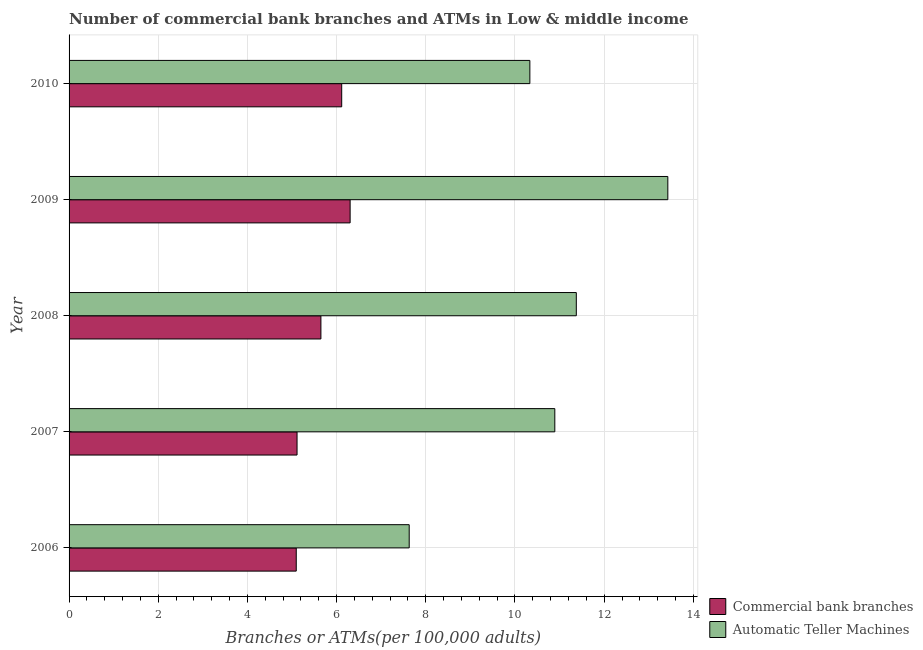How many different coloured bars are there?
Provide a short and direct response. 2. Are the number of bars on each tick of the Y-axis equal?
Provide a succinct answer. Yes. How many bars are there on the 2nd tick from the bottom?
Offer a very short reply. 2. What is the label of the 1st group of bars from the top?
Offer a terse response. 2010. What is the number of atms in 2008?
Your answer should be very brief. 11.38. Across all years, what is the maximum number of commercal bank branches?
Provide a succinct answer. 6.3. Across all years, what is the minimum number of atms?
Provide a succinct answer. 7.63. In which year was the number of commercal bank branches minimum?
Provide a short and direct response. 2006. What is the total number of commercal bank branches in the graph?
Offer a terse response. 28.27. What is the difference between the number of commercal bank branches in 2008 and that in 2009?
Make the answer very short. -0.66. What is the difference between the number of commercal bank branches in 2009 and the number of atms in 2008?
Give a very brief answer. -5.07. What is the average number of atms per year?
Give a very brief answer. 10.73. In the year 2008, what is the difference between the number of commercal bank branches and number of atms?
Your response must be concise. -5.73. In how many years, is the number of commercal bank branches greater than 10.8 ?
Your answer should be very brief. 0. What is the ratio of the number of atms in 2007 to that in 2010?
Your response must be concise. 1.05. What is the difference between the highest and the second highest number of atms?
Make the answer very short. 2.05. What is the difference between the highest and the lowest number of commercal bank branches?
Your answer should be very brief. 1.21. What does the 2nd bar from the top in 2010 represents?
Give a very brief answer. Commercial bank branches. What does the 2nd bar from the bottom in 2010 represents?
Provide a succinct answer. Automatic Teller Machines. Are all the bars in the graph horizontal?
Provide a succinct answer. Yes. How many years are there in the graph?
Offer a terse response. 5. Are the values on the major ticks of X-axis written in scientific E-notation?
Offer a very short reply. No. Does the graph contain any zero values?
Provide a short and direct response. No. Does the graph contain grids?
Your answer should be very brief. Yes. How are the legend labels stacked?
Provide a short and direct response. Vertical. What is the title of the graph?
Your answer should be very brief. Number of commercial bank branches and ATMs in Low & middle income. What is the label or title of the X-axis?
Offer a very short reply. Branches or ATMs(per 100,0 adults). What is the Branches or ATMs(per 100,000 adults) of Commercial bank branches in 2006?
Offer a very short reply. 5.09. What is the Branches or ATMs(per 100,000 adults) of Automatic Teller Machines in 2006?
Give a very brief answer. 7.63. What is the Branches or ATMs(per 100,000 adults) of Commercial bank branches in 2007?
Your response must be concise. 5.11. What is the Branches or ATMs(per 100,000 adults) in Automatic Teller Machines in 2007?
Your response must be concise. 10.89. What is the Branches or ATMs(per 100,000 adults) of Commercial bank branches in 2008?
Offer a terse response. 5.65. What is the Branches or ATMs(per 100,000 adults) of Automatic Teller Machines in 2008?
Offer a terse response. 11.38. What is the Branches or ATMs(per 100,000 adults) of Commercial bank branches in 2009?
Your answer should be very brief. 6.3. What is the Branches or ATMs(per 100,000 adults) in Automatic Teller Machines in 2009?
Give a very brief answer. 13.43. What is the Branches or ATMs(per 100,000 adults) in Commercial bank branches in 2010?
Your answer should be very brief. 6.11. What is the Branches or ATMs(per 100,000 adults) in Automatic Teller Machines in 2010?
Keep it short and to the point. 10.33. Across all years, what is the maximum Branches or ATMs(per 100,000 adults) of Commercial bank branches?
Your answer should be very brief. 6.3. Across all years, what is the maximum Branches or ATMs(per 100,000 adults) in Automatic Teller Machines?
Keep it short and to the point. 13.43. Across all years, what is the minimum Branches or ATMs(per 100,000 adults) in Commercial bank branches?
Ensure brevity in your answer.  5.09. Across all years, what is the minimum Branches or ATMs(per 100,000 adults) of Automatic Teller Machines?
Keep it short and to the point. 7.63. What is the total Branches or ATMs(per 100,000 adults) of Commercial bank branches in the graph?
Offer a very short reply. 28.27. What is the total Branches or ATMs(per 100,000 adults) in Automatic Teller Machines in the graph?
Your answer should be compact. 53.66. What is the difference between the Branches or ATMs(per 100,000 adults) in Commercial bank branches in 2006 and that in 2007?
Give a very brief answer. -0.02. What is the difference between the Branches or ATMs(per 100,000 adults) in Automatic Teller Machines in 2006 and that in 2007?
Your response must be concise. -3.27. What is the difference between the Branches or ATMs(per 100,000 adults) of Commercial bank branches in 2006 and that in 2008?
Provide a succinct answer. -0.55. What is the difference between the Branches or ATMs(per 100,000 adults) in Automatic Teller Machines in 2006 and that in 2008?
Provide a succinct answer. -3.75. What is the difference between the Branches or ATMs(per 100,000 adults) of Commercial bank branches in 2006 and that in 2009?
Offer a terse response. -1.21. What is the difference between the Branches or ATMs(per 100,000 adults) in Automatic Teller Machines in 2006 and that in 2009?
Your answer should be very brief. -5.8. What is the difference between the Branches or ATMs(per 100,000 adults) of Commercial bank branches in 2006 and that in 2010?
Your answer should be compact. -1.02. What is the difference between the Branches or ATMs(per 100,000 adults) of Automatic Teller Machines in 2006 and that in 2010?
Your answer should be compact. -2.71. What is the difference between the Branches or ATMs(per 100,000 adults) of Commercial bank branches in 2007 and that in 2008?
Keep it short and to the point. -0.53. What is the difference between the Branches or ATMs(per 100,000 adults) in Automatic Teller Machines in 2007 and that in 2008?
Provide a short and direct response. -0.48. What is the difference between the Branches or ATMs(per 100,000 adults) of Commercial bank branches in 2007 and that in 2009?
Your answer should be compact. -1.19. What is the difference between the Branches or ATMs(per 100,000 adults) in Automatic Teller Machines in 2007 and that in 2009?
Ensure brevity in your answer.  -2.53. What is the difference between the Branches or ATMs(per 100,000 adults) of Commercial bank branches in 2007 and that in 2010?
Provide a succinct answer. -1. What is the difference between the Branches or ATMs(per 100,000 adults) in Automatic Teller Machines in 2007 and that in 2010?
Provide a short and direct response. 0.56. What is the difference between the Branches or ATMs(per 100,000 adults) in Commercial bank branches in 2008 and that in 2009?
Your response must be concise. -0.66. What is the difference between the Branches or ATMs(per 100,000 adults) of Automatic Teller Machines in 2008 and that in 2009?
Offer a very short reply. -2.05. What is the difference between the Branches or ATMs(per 100,000 adults) in Commercial bank branches in 2008 and that in 2010?
Provide a short and direct response. -0.47. What is the difference between the Branches or ATMs(per 100,000 adults) of Automatic Teller Machines in 2008 and that in 2010?
Offer a very short reply. 1.04. What is the difference between the Branches or ATMs(per 100,000 adults) of Commercial bank branches in 2009 and that in 2010?
Keep it short and to the point. 0.19. What is the difference between the Branches or ATMs(per 100,000 adults) in Automatic Teller Machines in 2009 and that in 2010?
Offer a very short reply. 3.09. What is the difference between the Branches or ATMs(per 100,000 adults) in Commercial bank branches in 2006 and the Branches or ATMs(per 100,000 adults) in Automatic Teller Machines in 2007?
Offer a very short reply. -5.8. What is the difference between the Branches or ATMs(per 100,000 adults) of Commercial bank branches in 2006 and the Branches or ATMs(per 100,000 adults) of Automatic Teller Machines in 2008?
Provide a short and direct response. -6.28. What is the difference between the Branches or ATMs(per 100,000 adults) in Commercial bank branches in 2006 and the Branches or ATMs(per 100,000 adults) in Automatic Teller Machines in 2009?
Your response must be concise. -8.33. What is the difference between the Branches or ATMs(per 100,000 adults) in Commercial bank branches in 2006 and the Branches or ATMs(per 100,000 adults) in Automatic Teller Machines in 2010?
Make the answer very short. -5.24. What is the difference between the Branches or ATMs(per 100,000 adults) of Commercial bank branches in 2007 and the Branches or ATMs(per 100,000 adults) of Automatic Teller Machines in 2008?
Make the answer very short. -6.26. What is the difference between the Branches or ATMs(per 100,000 adults) in Commercial bank branches in 2007 and the Branches or ATMs(per 100,000 adults) in Automatic Teller Machines in 2009?
Give a very brief answer. -8.31. What is the difference between the Branches or ATMs(per 100,000 adults) in Commercial bank branches in 2007 and the Branches or ATMs(per 100,000 adults) in Automatic Teller Machines in 2010?
Keep it short and to the point. -5.22. What is the difference between the Branches or ATMs(per 100,000 adults) in Commercial bank branches in 2008 and the Branches or ATMs(per 100,000 adults) in Automatic Teller Machines in 2009?
Your response must be concise. -7.78. What is the difference between the Branches or ATMs(per 100,000 adults) of Commercial bank branches in 2008 and the Branches or ATMs(per 100,000 adults) of Automatic Teller Machines in 2010?
Keep it short and to the point. -4.69. What is the difference between the Branches or ATMs(per 100,000 adults) of Commercial bank branches in 2009 and the Branches or ATMs(per 100,000 adults) of Automatic Teller Machines in 2010?
Your answer should be very brief. -4.03. What is the average Branches or ATMs(per 100,000 adults) of Commercial bank branches per year?
Your answer should be very brief. 5.65. What is the average Branches or ATMs(per 100,000 adults) of Automatic Teller Machines per year?
Your answer should be very brief. 10.73. In the year 2006, what is the difference between the Branches or ATMs(per 100,000 adults) in Commercial bank branches and Branches or ATMs(per 100,000 adults) in Automatic Teller Machines?
Offer a very short reply. -2.53. In the year 2007, what is the difference between the Branches or ATMs(per 100,000 adults) in Commercial bank branches and Branches or ATMs(per 100,000 adults) in Automatic Teller Machines?
Provide a succinct answer. -5.78. In the year 2008, what is the difference between the Branches or ATMs(per 100,000 adults) in Commercial bank branches and Branches or ATMs(per 100,000 adults) in Automatic Teller Machines?
Offer a very short reply. -5.73. In the year 2009, what is the difference between the Branches or ATMs(per 100,000 adults) of Commercial bank branches and Branches or ATMs(per 100,000 adults) of Automatic Teller Machines?
Your answer should be very brief. -7.12. In the year 2010, what is the difference between the Branches or ATMs(per 100,000 adults) of Commercial bank branches and Branches or ATMs(per 100,000 adults) of Automatic Teller Machines?
Your answer should be compact. -4.22. What is the ratio of the Branches or ATMs(per 100,000 adults) in Commercial bank branches in 2006 to that in 2007?
Give a very brief answer. 1. What is the ratio of the Branches or ATMs(per 100,000 adults) in Automatic Teller Machines in 2006 to that in 2007?
Your answer should be very brief. 0.7. What is the ratio of the Branches or ATMs(per 100,000 adults) of Commercial bank branches in 2006 to that in 2008?
Provide a succinct answer. 0.9. What is the ratio of the Branches or ATMs(per 100,000 adults) of Automatic Teller Machines in 2006 to that in 2008?
Offer a terse response. 0.67. What is the ratio of the Branches or ATMs(per 100,000 adults) of Commercial bank branches in 2006 to that in 2009?
Offer a terse response. 0.81. What is the ratio of the Branches or ATMs(per 100,000 adults) in Automatic Teller Machines in 2006 to that in 2009?
Offer a very short reply. 0.57. What is the ratio of the Branches or ATMs(per 100,000 adults) of Commercial bank branches in 2006 to that in 2010?
Your response must be concise. 0.83. What is the ratio of the Branches or ATMs(per 100,000 adults) in Automatic Teller Machines in 2006 to that in 2010?
Give a very brief answer. 0.74. What is the ratio of the Branches or ATMs(per 100,000 adults) of Commercial bank branches in 2007 to that in 2008?
Offer a terse response. 0.91. What is the ratio of the Branches or ATMs(per 100,000 adults) of Automatic Teller Machines in 2007 to that in 2008?
Keep it short and to the point. 0.96. What is the ratio of the Branches or ATMs(per 100,000 adults) in Commercial bank branches in 2007 to that in 2009?
Keep it short and to the point. 0.81. What is the ratio of the Branches or ATMs(per 100,000 adults) of Automatic Teller Machines in 2007 to that in 2009?
Make the answer very short. 0.81. What is the ratio of the Branches or ATMs(per 100,000 adults) of Commercial bank branches in 2007 to that in 2010?
Provide a short and direct response. 0.84. What is the ratio of the Branches or ATMs(per 100,000 adults) in Automatic Teller Machines in 2007 to that in 2010?
Give a very brief answer. 1.05. What is the ratio of the Branches or ATMs(per 100,000 adults) of Commercial bank branches in 2008 to that in 2009?
Your answer should be very brief. 0.9. What is the ratio of the Branches or ATMs(per 100,000 adults) in Automatic Teller Machines in 2008 to that in 2009?
Your answer should be compact. 0.85. What is the ratio of the Branches or ATMs(per 100,000 adults) in Commercial bank branches in 2008 to that in 2010?
Make the answer very short. 0.92. What is the ratio of the Branches or ATMs(per 100,000 adults) of Automatic Teller Machines in 2008 to that in 2010?
Your answer should be compact. 1.1. What is the ratio of the Branches or ATMs(per 100,000 adults) in Commercial bank branches in 2009 to that in 2010?
Keep it short and to the point. 1.03. What is the ratio of the Branches or ATMs(per 100,000 adults) in Automatic Teller Machines in 2009 to that in 2010?
Your answer should be compact. 1.3. What is the difference between the highest and the second highest Branches or ATMs(per 100,000 adults) of Commercial bank branches?
Ensure brevity in your answer.  0.19. What is the difference between the highest and the second highest Branches or ATMs(per 100,000 adults) in Automatic Teller Machines?
Your answer should be compact. 2.05. What is the difference between the highest and the lowest Branches or ATMs(per 100,000 adults) of Commercial bank branches?
Your answer should be very brief. 1.21. What is the difference between the highest and the lowest Branches or ATMs(per 100,000 adults) in Automatic Teller Machines?
Keep it short and to the point. 5.8. 